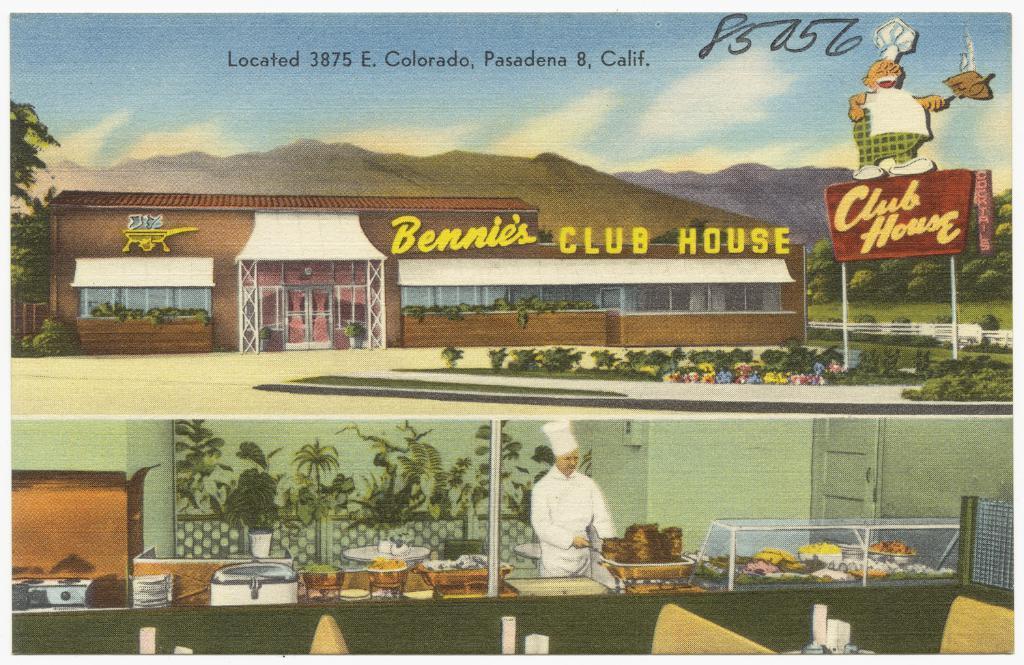Describe this image in one or two sentences. This is a poster. Here we can see a building, board, plants, trees, bowls, and food. There is a man preparing food. This is wall and there is a door. There is sky with clouds. 